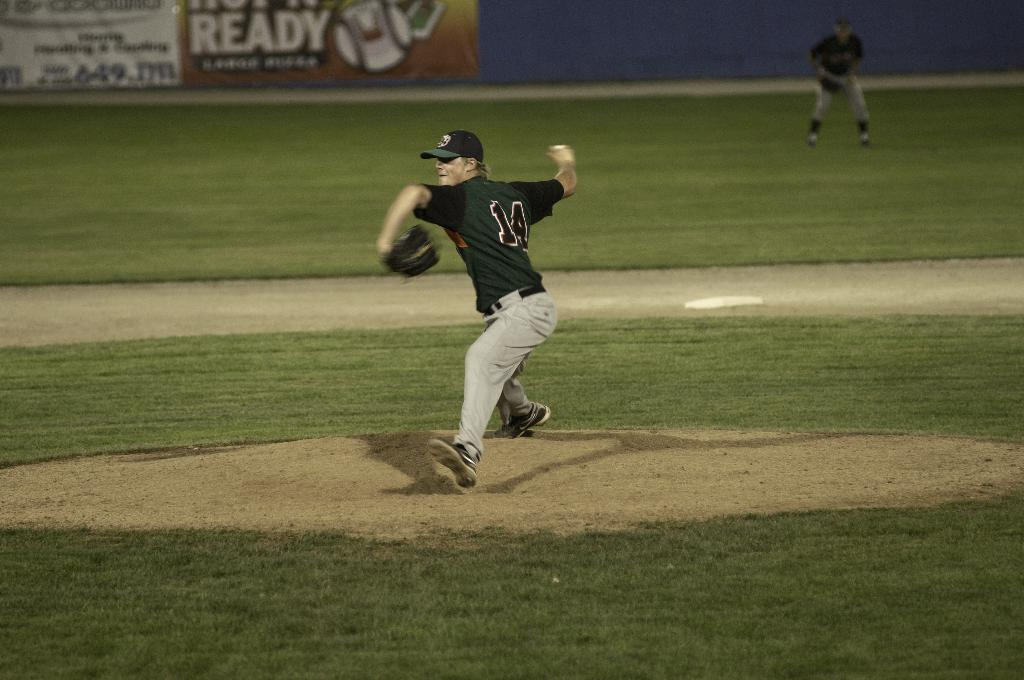Provide a one-sentence caption for the provided image. A pitcher in a navy blue shirt with the number 14 is throwing a pitch. 